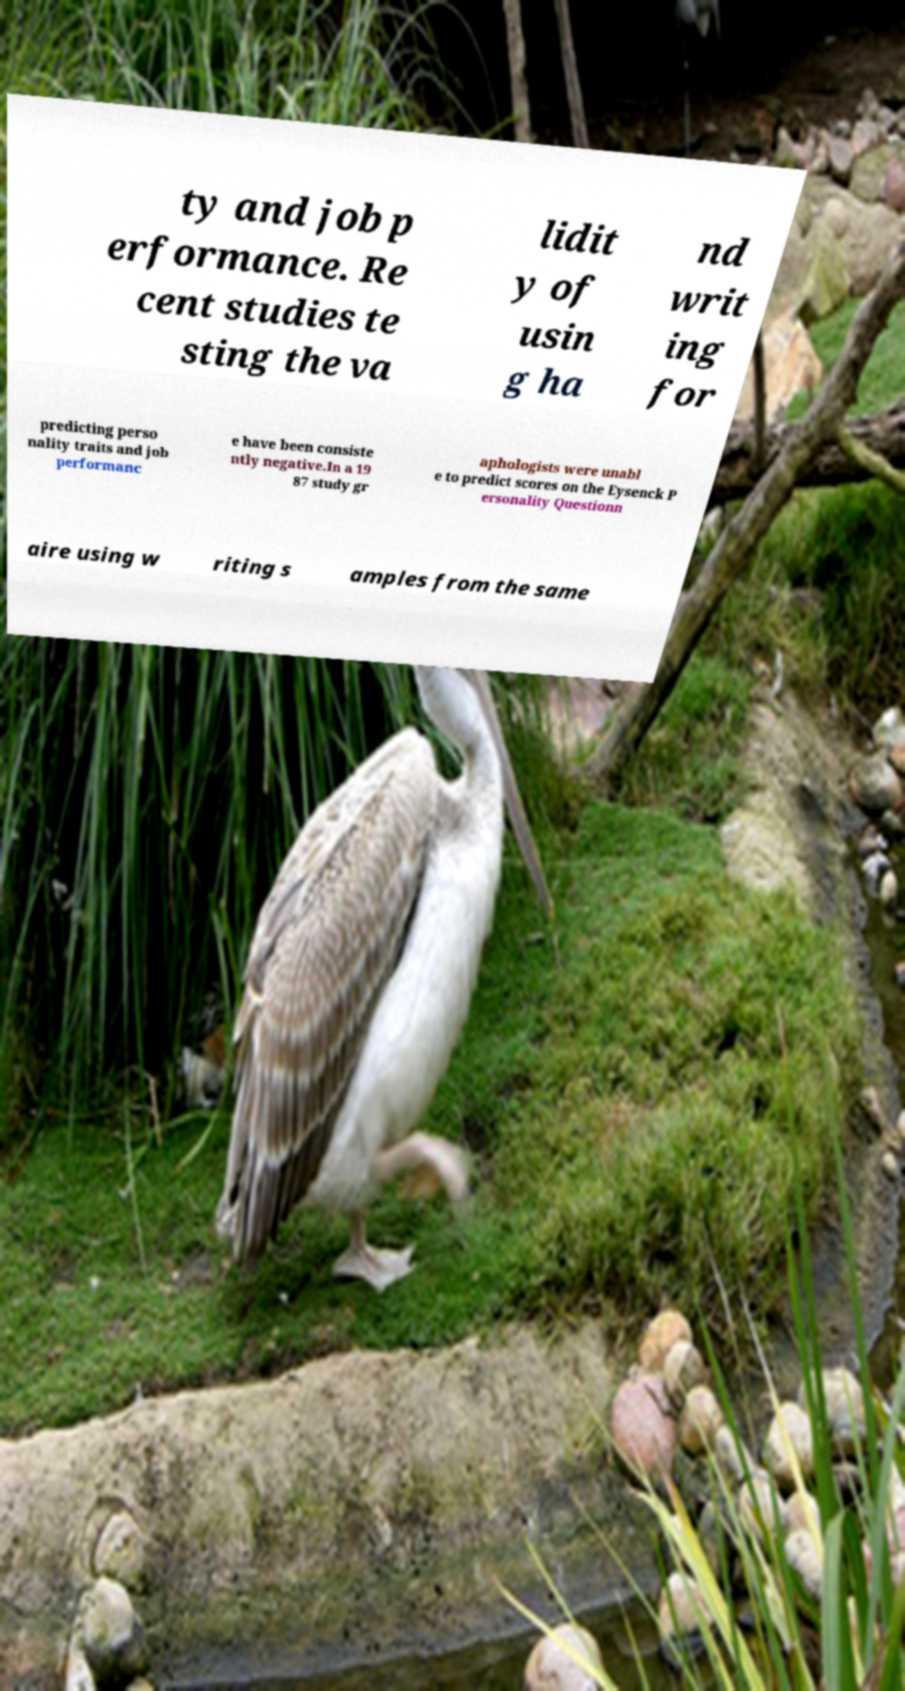There's text embedded in this image that I need extracted. Can you transcribe it verbatim? ty and job p erformance. Re cent studies te sting the va lidit y of usin g ha nd writ ing for predicting perso nality traits and job performanc e have been consiste ntly negative.In a 19 87 study gr aphologists were unabl e to predict scores on the Eysenck P ersonality Questionn aire using w riting s amples from the same 